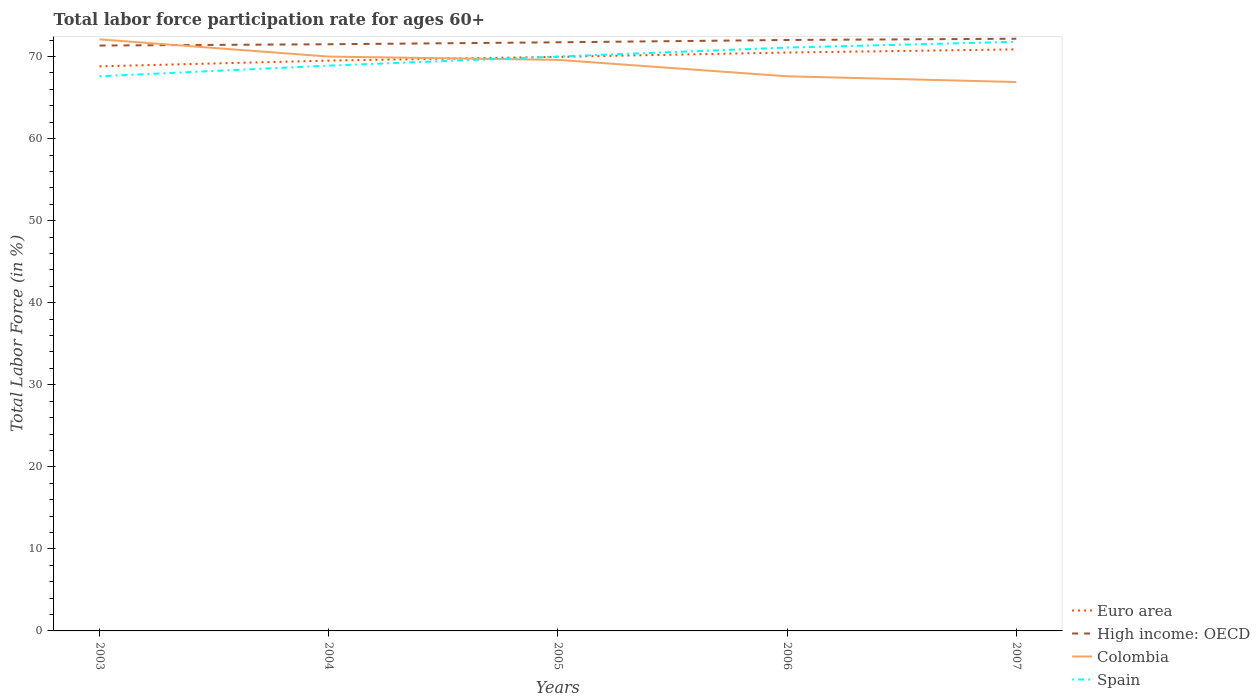Does the line corresponding to Spain intersect with the line corresponding to Euro area?
Your response must be concise. Yes. Across all years, what is the maximum labor force participation rate in High income: OECD?
Make the answer very short. 71.35. In which year was the labor force participation rate in Euro area maximum?
Give a very brief answer. 2003. What is the total labor force participation rate in Euro area in the graph?
Keep it short and to the point. -2.06. What is the difference between the highest and the second highest labor force participation rate in Colombia?
Your response must be concise. 5.2. Is the labor force participation rate in Colombia strictly greater than the labor force participation rate in Spain over the years?
Your response must be concise. No. How many lines are there?
Offer a terse response. 4. How many years are there in the graph?
Ensure brevity in your answer.  5. What is the difference between two consecutive major ticks on the Y-axis?
Ensure brevity in your answer.  10. Does the graph contain grids?
Your answer should be compact. No. Where does the legend appear in the graph?
Offer a very short reply. Bottom right. How many legend labels are there?
Your answer should be compact. 4. What is the title of the graph?
Keep it short and to the point. Total labor force participation rate for ages 60+. What is the label or title of the X-axis?
Ensure brevity in your answer.  Years. What is the Total Labor Force (in %) in Euro area in 2003?
Your response must be concise. 68.81. What is the Total Labor Force (in %) in High income: OECD in 2003?
Your answer should be very brief. 71.35. What is the Total Labor Force (in %) of Colombia in 2003?
Provide a succinct answer. 72.1. What is the Total Labor Force (in %) of Spain in 2003?
Give a very brief answer. 67.6. What is the Total Labor Force (in %) of Euro area in 2004?
Your response must be concise. 69.51. What is the Total Labor Force (in %) in High income: OECD in 2004?
Your answer should be compact. 71.5. What is the Total Labor Force (in %) in Colombia in 2004?
Your answer should be compact. 70. What is the Total Labor Force (in %) in Spain in 2004?
Keep it short and to the point. 68.9. What is the Total Labor Force (in %) of Euro area in 2005?
Offer a very short reply. 69.97. What is the Total Labor Force (in %) in High income: OECD in 2005?
Offer a terse response. 71.74. What is the Total Labor Force (in %) in Colombia in 2005?
Ensure brevity in your answer.  69.6. What is the Total Labor Force (in %) in Euro area in 2006?
Your response must be concise. 70.49. What is the Total Labor Force (in %) in High income: OECD in 2006?
Give a very brief answer. 72.02. What is the Total Labor Force (in %) of Colombia in 2006?
Your response must be concise. 67.6. What is the Total Labor Force (in %) in Spain in 2006?
Ensure brevity in your answer.  71.1. What is the Total Labor Force (in %) of Euro area in 2007?
Offer a very short reply. 70.88. What is the Total Labor Force (in %) in High income: OECD in 2007?
Your answer should be very brief. 72.18. What is the Total Labor Force (in %) of Colombia in 2007?
Provide a short and direct response. 66.9. What is the Total Labor Force (in %) of Spain in 2007?
Your answer should be compact. 71.8. Across all years, what is the maximum Total Labor Force (in %) in Euro area?
Your answer should be compact. 70.88. Across all years, what is the maximum Total Labor Force (in %) in High income: OECD?
Offer a very short reply. 72.18. Across all years, what is the maximum Total Labor Force (in %) in Colombia?
Your answer should be very brief. 72.1. Across all years, what is the maximum Total Labor Force (in %) in Spain?
Your response must be concise. 71.8. Across all years, what is the minimum Total Labor Force (in %) in Euro area?
Keep it short and to the point. 68.81. Across all years, what is the minimum Total Labor Force (in %) of High income: OECD?
Offer a very short reply. 71.35. Across all years, what is the minimum Total Labor Force (in %) of Colombia?
Provide a succinct answer. 66.9. Across all years, what is the minimum Total Labor Force (in %) of Spain?
Ensure brevity in your answer.  67.6. What is the total Total Labor Force (in %) of Euro area in the graph?
Provide a succinct answer. 349.67. What is the total Total Labor Force (in %) in High income: OECD in the graph?
Provide a succinct answer. 358.79. What is the total Total Labor Force (in %) of Colombia in the graph?
Offer a very short reply. 346.2. What is the total Total Labor Force (in %) of Spain in the graph?
Offer a very short reply. 349.4. What is the difference between the Total Labor Force (in %) in Euro area in 2003 and that in 2004?
Offer a very short reply. -0.69. What is the difference between the Total Labor Force (in %) in High income: OECD in 2003 and that in 2004?
Your response must be concise. -0.16. What is the difference between the Total Labor Force (in %) of Colombia in 2003 and that in 2004?
Provide a succinct answer. 2.1. What is the difference between the Total Labor Force (in %) of Spain in 2003 and that in 2004?
Your answer should be compact. -1.3. What is the difference between the Total Labor Force (in %) of Euro area in 2003 and that in 2005?
Keep it short and to the point. -1.16. What is the difference between the Total Labor Force (in %) of High income: OECD in 2003 and that in 2005?
Ensure brevity in your answer.  -0.4. What is the difference between the Total Labor Force (in %) in Euro area in 2003 and that in 2006?
Your answer should be very brief. -1.68. What is the difference between the Total Labor Force (in %) in High income: OECD in 2003 and that in 2006?
Keep it short and to the point. -0.68. What is the difference between the Total Labor Force (in %) in Spain in 2003 and that in 2006?
Your response must be concise. -3.5. What is the difference between the Total Labor Force (in %) of Euro area in 2003 and that in 2007?
Your response must be concise. -2.06. What is the difference between the Total Labor Force (in %) in High income: OECD in 2003 and that in 2007?
Your answer should be very brief. -0.83. What is the difference between the Total Labor Force (in %) of Spain in 2003 and that in 2007?
Offer a terse response. -4.2. What is the difference between the Total Labor Force (in %) in Euro area in 2004 and that in 2005?
Keep it short and to the point. -0.46. What is the difference between the Total Labor Force (in %) of High income: OECD in 2004 and that in 2005?
Ensure brevity in your answer.  -0.24. What is the difference between the Total Labor Force (in %) of Colombia in 2004 and that in 2005?
Your answer should be compact. 0.4. What is the difference between the Total Labor Force (in %) of Euro area in 2004 and that in 2006?
Give a very brief answer. -0.98. What is the difference between the Total Labor Force (in %) of High income: OECD in 2004 and that in 2006?
Offer a terse response. -0.52. What is the difference between the Total Labor Force (in %) of Spain in 2004 and that in 2006?
Ensure brevity in your answer.  -2.2. What is the difference between the Total Labor Force (in %) in Euro area in 2004 and that in 2007?
Your response must be concise. -1.37. What is the difference between the Total Labor Force (in %) in High income: OECD in 2004 and that in 2007?
Offer a terse response. -0.67. What is the difference between the Total Labor Force (in %) in Euro area in 2005 and that in 2006?
Provide a succinct answer. -0.52. What is the difference between the Total Labor Force (in %) in High income: OECD in 2005 and that in 2006?
Give a very brief answer. -0.28. What is the difference between the Total Labor Force (in %) in Spain in 2005 and that in 2006?
Give a very brief answer. -1.1. What is the difference between the Total Labor Force (in %) of Euro area in 2005 and that in 2007?
Your answer should be very brief. -0.91. What is the difference between the Total Labor Force (in %) in High income: OECD in 2005 and that in 2007?
Provide a succinct answer. -0.43. What is the difference between the Total Labor Force (in %) in Spain in 2005 and that in 2007?
Your response must be concise. -1.8. What is the difference between the Total Labor Force (in %) in Euro area in 2006 and that in 2007?
Keep it short and to the point. -0.38. What is the difference between the Total Labor Force (in %) of High income: OECD in 2006 and that in 2007?
Your answer should be very brief. -0.15. What is the difference between the Total Labor Force (in %) in Euro area in 2003 and the Total Labor Force (in %) in High income: OECD in 2004?
Make the answer very short. -2.69. What is the difference between the Total Labor Force (in %) of Euro area in 2003 and the Total Labor Force (in %) of Colombia in 2004?
Ensure brevity in your answer.  -1.19. What is the difference between the Total Labor Force (in %) in Euro area in 2003 and the Total Labor Force (in %) in Spain in 2004?
Offer a terse response. -0.09. What is the difference between the Total Labor Force (in %) in High income: OECD in 2003 and the Total Labor Force (in %) in Colombia in 2004?
Offer a very short reply. 1.35. What is the difference between the Total Labor Force (in %) in High income: OECD in 2003 and the Total Labor Force (in %) in Spain in 2004?
Give a very brief answer. 2.45. What is the difference between the Total Labor Force (in %) in Euro area in 2003 and the Total Labor Force (in %) in High income: OECD in 2005?
Your answer should be compact. -2.93. What is the difference between the Total Labor Force (in %) in Euro area in 2003 and the Total Labor Force (in %) in Colombia in 2005?
Offer a terse response. -0.79. What is the difference between the Total Labor Force (in %) in Euro area in 2003 and the Total Labor Force (in %) in Spain in 2005?
Offer a very short reply. -1.19. What is the difference between the Total Labor Force (in %) of High income: OECD in 2003 and the Total Labor Force (in %) of Colombia in 2005?
Make the answer very short. 1.75. What is the difference between the Total Labor Force (in %) in High income: OECD in 2003 and the Total Labor Force (in %) in Spain in 2005?
Your answer should be compact. 1.35. What is the difference between the Total Labor Force (in %) of Euro area in 2003 and the Total Labor Force (in %) of High income: OECD in 2006?
Keep it short and to the point. -3.21. What is the difference between the Total Labor Force (in %) of Euro area in 2003 and the Total Labor Force (in %) of Colombia in 2006?
Offer a very short reply. 1.21. What is the difference between the Total Labor Force (in %) of Euro area in 2003 and the Total Labor Force (in %) of Spain in 2006?
Your answer should be compact. -2.29. What is the difference between the Total Labor Force (in %) in High income: OECD in 2003 and the Total Labor Force (in %) in Colombia in 2006?
Offer a very short reply. 3.75. What is the difference between the Total Labor Force (in %) of High income: OECD in 2003 and the Total Labor Force (in %) of Spain in 2006?
Give a very brief answer. 0.25. What is the difference between the Total Labor Force (in %) of Euro area in 2003 and the Total Labor Force (in %) of High income: OECD in 2007?
Provide a short and direct response. -3.36. What is the difference between the Total Labor Force (in %) in Euro area in 2003 and the Total Labor Force (in %) in Colombia in 2007?
Give a very brief answer. 1.91. What is the difference between the Total Labor Force (in %) in Euro area in 2003 and the Total Labor Force (in %) in Spain in 2007?
Your answer should be very brief. -2.99. What is the difference between the Total Labor Force (in %) of High income: OECD in 2003 and the Total Labor Force (in %) of Colombia in 2007?
Give a very brief answer. 4.45. What is the difference between the Total Labor Force (in %) in High income: OECD in 2003 and the Total Labor Force (in %) in Spain in 2007?
Give a very brief answer. -0.45. What is the difference between the Total Labor Force (in %) of Colombia in 2003 and the Total Labor Force (in %) of Spain in 2007?
Make the answer very short. 0.3. What is the difference between the Total Labor Force (in %) of Euro area in 2004 and the Total Labor Force (in %) of High income: OECD in 2005?
Offer a very short reply. -2.23. What is the difference between the Total Labor Force (in %) of Euro area in 2004 and the Total Labor Force (in %) of Colombia in 2005?
Provide a short and direct response. -0.09. What is the difference between the Total Labor Force (in %) in Euro area in 2004 and the Total Labor Force (in %) in Spain in 2005?
Keep it short and to the point. -0.49. What is the difference between the Total Labor Force (in %) of High income: OECD in 2004 and the Total Labor Force (in %) of Colombia in 2005?
Ensure brevity in your answer.  1.9. What is the difference between the Total Labor Force (in %) of High income: OECD in 2004 and the Total Labor Force (in %) of Spain in 2005?
Your answer should be compact. 1.5. What is the difference between the Total Labor Force (in %) in Colombia in 2004 and the Total Labor Force (in %) in Spain in 2005?
Provide a short and direct response. 0. What is the difference between the Total Labor Force (in %) in Euro area in 2004 and the Total Labor Force (in %) in High income: OECD in 2006?
Your answer should be compact. -2.51. What is the difference between the Total Labor Force (in %) in Euro area in 2004 and the Total Labor Force (in %) in Colombia in 2006?
Your answer should be very brief. 1.91. What is the difference between the Total Labor Force (in %) in Euro area in 2004 and the Total Labor Force (in %) in Spain in 2006?
Offer a very short reply. -1.59. What is the difference between the Total Labor Force (in %) of High income: OECD in 2004 and the Total Labor Force (in %) of Colombia in 2006?
Your answer should be compact. 3.9. What is the difference between the Total Labor Force (in %) in High income: OECD in 2004 and the Total Labor Force (in %) in Spain in 2006?
Ensure brevity in your answer.  0.4. What is the difference between the Total Labor Force (in %) in Euro area in 2004 and the Total Labor Force (in %) in High income: OECD in 2007?
Ensure brevity in your answer.  -2.67. What is the difference between the Total Labor Force (in %) in Euro area in 2004 and the Total Labor Force (in %) in Colombia in 2007?
Your answer should be compact. 2.61. What is the difference between the Total Labor Force (in %) of Euro area in 2004 and the Total Labor Force (in %) of Spain in 2007?
Offer a very short reply. -2.29. What is the difference between the Total Labor Force (in %) in High income: OECD in 2004 and the Total Labor Force (in %) in Colombia in 2007?
Provide a short and direct response. 4.6. What is the difference between the Total Labor Force (in %) of High income: OECD in 2004 and the Total Labor Force (in %) of Spain in 2007?
Your response must be concise. -0.3. What is the difference between the Total Labor Force (in %) of Euro area in 2005 and the Total Labor Force (in %) of High income: OECD in 2006?
Offer a terse response. -2.05. What is the difference between the Total Labor Force (in %) in Euro area in 2005 and the Total Labor Force (in %) in Colombia in 2006?
Provide a short and direct response. 2.37. What is the difference between the Total Labor Force (in %) of Euro area in 2005 and the Total Labor Force (in %) of Spain in 2006?
Keep it short and to the point. -1.13. What is the difference between the Total Labor Force (in %) in High income: OECD in 2005 and the Total Labor Force (in %) in Colombia in 2006?
Your answer should be very brief. 4.14. What is the difference between the Total Labor Force (in %) of High income: OECD in 2005 and the Total Labor Force (in %) of Spain in 2006?
Make the answer very short. 0.64. What is the difference between the Total Labor Force (in %) in Euro area in 2005 and the Total Labor Force (in %) in High income: OECD in 2007?
Your response must be concise. -2.2. What is the difference between the Total Labor Force (in %) in Euro area in 2005 and the Total Labor Force (in %) in Colombia in 2007?
Your answer should be compact. 3.07. What is the difference between the Total Labor Force (in %) in Euro area in 2005 and the Total Labor Force (in %) in Spain in 2007?
Keep it short and to the point. -1.83. What is the difference between the Total Labor Force (in %) in High income: OECD in 2005 and the Total Labor Force (in %) in Colombia in 2007?
Your answer should be very brief. 4.84. What is the difference between the Total Labor Force (in %) in High income: OECD in 2005 and the Total Labor Force (in %) in Spain in 2007?
Offer a terse response. -0.06. What is the difference between the Total Labor Force (in %) in Colombia in 2005 and the Total Labor Force (in %) in Spain in 2007?
Give a very brief answer. -2.2. What is the difference between the Total Labor Force (in %) of Euro area in 2006 and the Total Labor Force (in %) of High income: OECD in 2007?
Keep it short and to the point. -1.68. What is the difference between the Total Labor Force (in %) in Euro area in 2006 and the Total Labor Force (in %) in Colombia in 2007?
Provide a short and direct response. 3.59. What is the difference between the Total Labor Force (in %) of Euro area in 2006 and the Total Labor Force (in %) of Spain in 2007?
Offer a very short reply. -1.31. What is the difference between the Total Labor Force (in %) of High income: OECD in 2006 and the Total Labor Force (in %) of Colombia in 2007?
Your answer should be compact. 5.12. What is the difference between the Total Labor Force (in %) in High income: OECD in 2006 and the Total Labor Force (in %) in Spain in 2007?
Give a very brief answer. 0.22. What is the average Total Labor Force (in %) of Euro area per year?
Provide a short and direct response. 69.93. What is the average Total Labor Force (in %) of High income: OECD per year?
Offer a very short reply. 71.76. What is the average Total Labor Force (in %) of Colombia per year?
Give a very brief answer. 69.24. What is the average Total Labor Force (in %) of Spain per year?
Provide a succinct answer. 69.88. In the year 2003, what is the difference between the Total Labor Force (in %) of Euro area and Total Labor Force (in %) of High income: OECD?
Provide a short and direct response. -2.53. In the year 2003, what is the difference between the Total Labor Force (in %) in Euro area and Total Labor Force (in %) in Colombia?
Your answer should be compact. -3.29. In the year 2003, what is the difference between the Total Labor Force (in %) of Euro area and Total Labor Force (in %) of Spain?
Your answer should be very brief. 1.21. In the year 2003, what is the difference between the Total Labor Force (in %) in High income: OECD and Total Labor Force (in %) in Colombia?
Provide a short and direct response. -0.75. In the year 2003, what is the difference between the Total Labor Force (in %) in High income: OECD and Total Labor Force (in %) in Spain?
Offer a very short reply. 3.75. In the year 2004, what is the difference between the Total Labor Force (in %) of Euro area and Total Labor Force (in %) of High income: OECD?
Your response must be concise. -1.99. In the year 2004, what is the difference between the Total Labor Force (in %) of Euro area and Total Labor Force (in %) of Colombia?
Your response must be concise. -0.49. In the year 2004, what is the difference between the Total Labor Force (in %) in Euro area and Total Labor Force (in %) in Spain?
Your answer should be very brief. 0.61. In the year 2004, what is the difference between the Total Labor Force (in %) in High income: OECD and Total Labor Force (in %) in Colombia?
Your response must be concise. 1.5. In the year 2004, what is the difference between the Total Labor Force (in %) of High income: OECD and Total Labor Force (in %) of Spain?
Ensure brevity in your answer.  2.6. In the year 2004, what is the difference between the Total Labor Force (in %) in Colombia and Total Labor Force (in %) in Spain?
Your answer should be very brief. 1.1. In the year 2005, what is the difference between the Total Labor Force (in %) in Euro area and Total Labor Force (in %) in High income: OECD?
Provide a short and direct response. -1.77. In the year 2005, what is the difference between the Total Labor Force (in %) in Euro area and Total Labor Force (in %) in Colombia?
Your answer should be compact. 0.37. In the year 2005, what is the difference between the Total Labor Force (in %) of Euro area and Total Labor Force (in %) of Spain?
Provide a short and direct response. -0.03. In the year 2005, what is the difference between the Total Labor Force (in %) of High income: OECD and Total Labor Force (in %) of Colombia?
Give a very brief answer. 2.14. In the year 2005, what is the difference between the Total Labor Force (in %) of High income: OECD and Total Labor Force (in %) of Spain?
Give a very brief answer. 1.74. In the year 2005, what is the difference between the Total Labor Force (in %) in Colombia and Total Labor Force (in %) in Spain?
Make the answer very short. -0.4. In the year 2006, what is the difference between the Total Labor Force (in %) of Euro area and Total Labor Force (in %) of High income: OECD?
Keep it short and to the point. -1.53. In the year 2006, what is the difference between the Total Labor Force (in %) in Euro area and Total Labor Force (in %) in Colombia?
Give a very brief answer. 2.89. In the year 2006, what is the difference between the Total Labor Force (in %) of Euro area and Total Labor Force (in %) of Spain?
Your answer should be compact. -0.61. In the year 2006, what is the difference between the Total Labor Force (in %) of High income: OECD and Total Labor Force (in %) of Colombia?
Ensure brevity in your answer.  4.42. In the year 2006, what is the difference between the Total Labor Force (in %) in High income: OECD and Total Labor Force (in %) in Spain?
Ensure brevity in your answer.  0.92. In the year 2006, what is the difference between the Total Labor Force (in %) of Colombia and Total Labor Force (in %) of Spain?
Ensure brevity in your answer.  -3.5. In the year 2007, what is the difference between the Total Labor Force (in %) in Euro area and Total Labor Force (in %) in High income: OECD?
Offer a very short reply. -1.3. In the year 2007, what is the difference between the Total Labor Force (in %) in Euro area and Total Labor Force (in %) in Colombia?
Your answer should be very brief. 3.98. In the year 2007, what is the difference between the Total Labor Force (in %) of Euro area and Total Labor Force (in %) of Spain?
Your response must be concise. -0.92. In the year 2007, what is the difference between the Total Labor Force (in %) of High income: OECD and Total Labor Force (in %) of Colombia?
Make the answer very short. 5.28. In the year 2007, what is the difference between the Total Labor Force (in %) of High income: OECD and Total Labor Force (in %) of Spain?
Provide a short and direct response. 0.38. In the year 2007, what is the difference between the Total Labor Force (in %) in Colombia and Total Labor Force (in %) in Spain?
Your answer should be very brief. -4.9. What is the ratio of the Total Labor Force (in %) in Euro area in 2003 to that in 2004?
Your answer should be compact. 0.99. What is the ratio of the Total Labor Force (in %) in High income: OECD in 2003 to that in 2004?
Offer a terse response. 1. What is the ratio of the Total Labor Force (in %) of Spain in 2003 to that in 2004?
Make the answer very short. 0.98. What is the ratio of the Total Labor Force (in %) of Euro area in 2003 to that in 2005?
Offer a very short reply. 0.98. What is the ratio of the Total Labor Force (in %) in Colombia in 2003 to that in 2005?
Offer a very short reply. 1.04. What is the ratio of the Total Labor Force (in %) in Spain in 2003 to that in 2005?
Your answer should be very brief. 0.97. What is the ratio of the Total Labor Force (in %) in Euro area in 2003 to that in 2006?
Offer a terse response. 0.98. What is the ratio of the Total Labor Force (in %) in High income: OECD in 2003 to that in 2006?
Keep it short and to the point. 0.99. What is the ratio of the Total Labor Force (in %) in Colombia in 2003 to that in 2006?
Your response must be concise. 1.07. What is the ratio of the Total Labor Force (in %) in Spain in 2003 to that in 2006?
Offer a very short reply. 0.95. What is the ratio of the Total Labor Force (in %) in Euro area in 2003 to that in 2007?
Your answer should be very brief. 0.97. What is the ratio of the Total Labor Force (in %) of High income: OECD in 2003 to that in 2007?
Offer a very short reply. 0.99. What is the ratio of the Total Labor Force (in %) of Colombia in 2003 to that in 2007?
Your answer should be compact. 1.08. What is the ratio of the Total Labor Force (in %) of Spain in 2003 to that in 2007?
Give a very brief answer. 0.94. What is the ratio of the Total Labor Force (in %) in High income: OECD in 2004 to that in 2005?
Your answer should be compact. 1. What is the ratio of the Total Labor Force (in %) of Colombia in 2004 to that in 2005?
Keep it short and to the point. 1.01. What is the ratio of the Total Labor Force (in %) of Spain in 2004 to that in 2005?
Keep it short and to the point. 0.98. What is the ratio of the Total Labor Force (in %) of Euro area in 2004 to that in 2006?
Keep it short and to the point. 0.99. What is the ratio of the Total Labor Force (in %) in Colombia in 2004 to that in 2006?
Your answer should be compact. 1.04. What is the ratio of the Total Labor Force (in %) of Spain in 2004 to that in 2006?
Make the answer very short. 0.97. What is the ratio of the Total Labor Force (in %) of Euro area in 2004 to that in 2007?
Offer a very short reply. 0.98. What is the ratio of the Total Labor Force (in %) of High income: OECD in 2004 to that in 2007?
Your answer should be very brief. 0.99. What is the ratio of the Total Labor Force (in %) of Colombia in 2004 to that in 2007?
Offer a very short reply. 1.05. What is the ratio of the Total Labor Force (in %) in Spain in 2004 to that in 2007?
Offer a very short reply. 0.96. What is the ratio of the Total Labor Force (in %) of Colombia in 2005 to that in 2006?
Offer a terse response. 1.03. What is the ratio of the Total Labor Force (in %) in Spain in 2005 to that in 2006?
Offer a terse response. 0.98. What is the ratio of the Total Labor Force (in %) of Euro area in 2005 to that in 2007?
Provide a short and direct response. 0.99. What is the ratio of the Total Labor Force (in %) of High income: OECD in 2005 to that in 2007?
Offer a terse response. 0.99. What is the ratio of the Total Labor Force (in %) in Colombia in 2005 to that in 2007?
Offer a terse response. 1.04. What is the ratio of the Total Labor Force (in %) in Spain in 2005 to that in 2007?
Keep it short and to the point. 0.97. What is the ratio of the Total Labor Force (in %) in Euro area in 2006 to that in 2007?
Your answer should be very brief. 0.99. What is the ratio of the Total Labor Force (in %) in Colombia in 2006 to that in 2007?
Your answer should be compact. 1.01. What is the ratio of the Total Labor Force (in %) of Spain in 2006 to that in 2007?
Your answer should be very brief. 0.99. What is the difference between the highest and the second highest Total Labor Force (in %) of Euro area?
Provide a succinct answer. 0.38. What is the difference between the highest and the second highest Total Labor Force (in %) in High income: OECD?
Give a very brief answer. 0.15. What is the difference between the highest and the second highest Total Labor Force (in %) in Colombia?
Your answer should be very brief. 2.1. What is the difference between the highest and the second highest Total Labor Force (in %) of Spain?
Offer a very short reply. 0.7. What is the difference between the highest and the lowest Total Labor Force (in %) of Euro area?
Give a very brief answer. 2.06. What is the difference between the highest and the lowest Total Labor Force (in %) in High income: OECD?
Offer a very short reply. 0.83. 